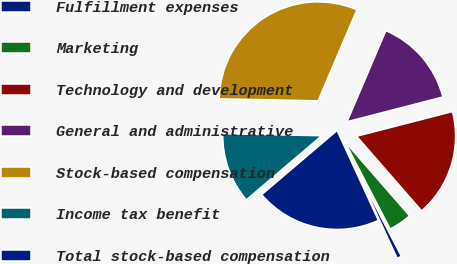<chart> <loc_0><loc_0><loc_500><loc_500><pie_chart><fcel>Fulfillment expenses<fcel>Marketing<fcel>Technology and development<fcel>General and administrative<fcel>Stock-based compensation<fcel>Income tax benefit<fcel>Total stock-based compensation<nl><fcel>0.76%<fcel>3.79%<fcel>17.61%<fcel>14.57%<fcel>31.1%<fcel>11.54%<fcel>20.64%<nl></chart> 